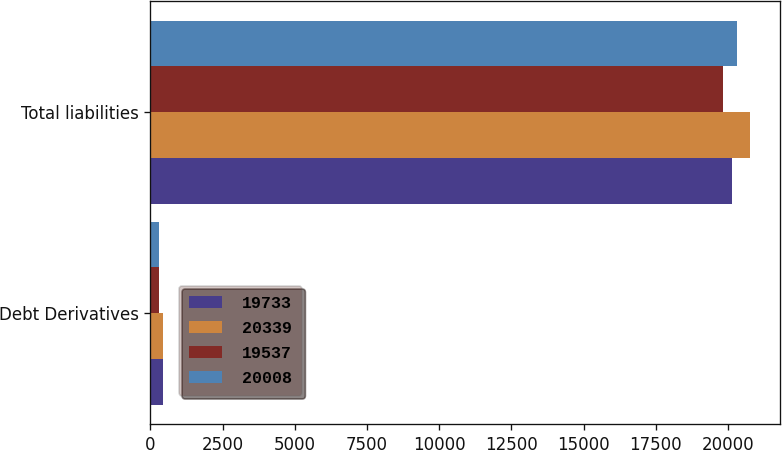<chart> <loc_0><loc_0><loc_500><loc_500><stacked_bar_chart><ecel><fcel>Debt Derivatives<fcel>Total liabilities<nl><fcel>19733<fcel>424<fcel>20157<nl><fcel>20339<fcel>424<fcel>20763<nl><fcel>19537<fcel>310<fcel>19847<nl><fcel>20008<fcel>310<fcel>20318<nl></chart> 